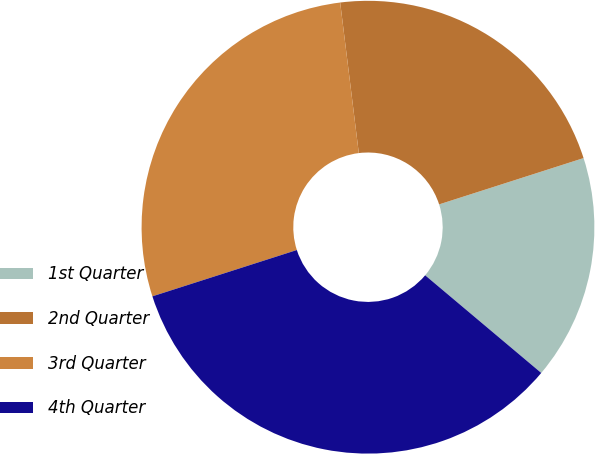<chart> <loc_0><loc_0><loc_500><loc_500><pie_chart><fcel>1st Quarter<fcel>2nd Quarter<fcel>3rd Quarter<fcel>4th Quarter<nl><fcel>16.07%<fcel>22.02%<fcel>27.98%<fcel>33.93%<nl></chart> 